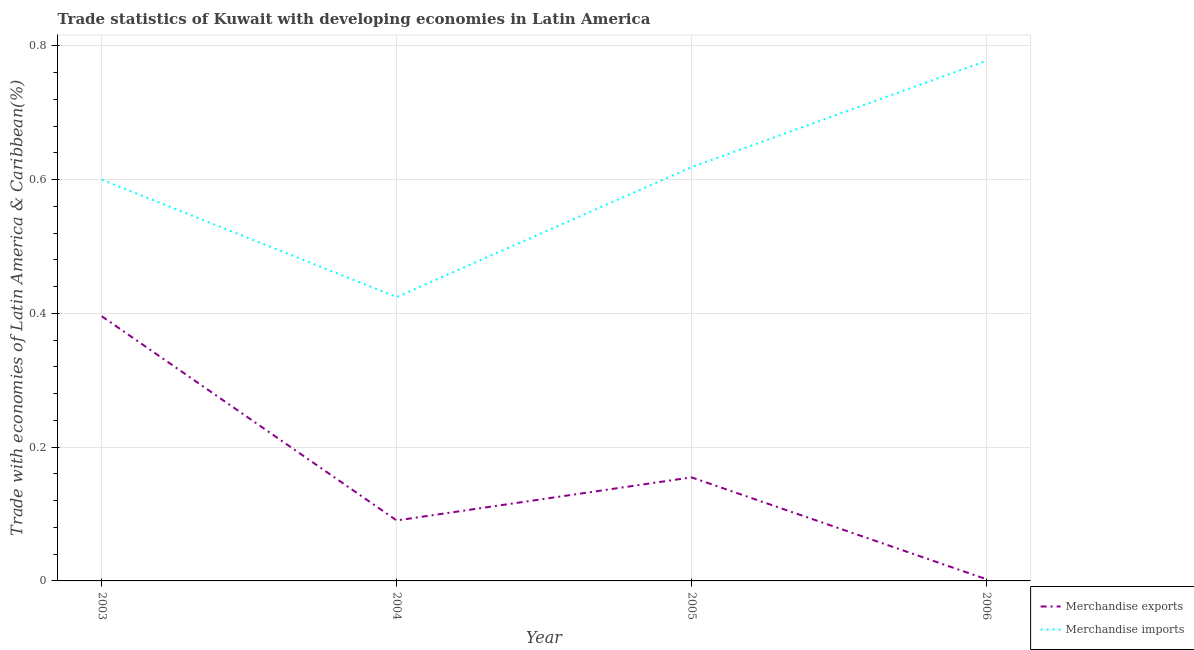How many different coloured lines are there?
Make the answer very short. 2. Does the line corresponding to merchandise imports intersect with the line corresponding to merchandise exports?
Give a very brief answer. No. Is the number of lines equal to the number of legend labels?
Keep it short and to the point. Yes. What is the merchandise exports in 2003?
Your answer should be compact. 0.4. Across all years, what is the maximum merchandise exports?
Your response must be concise. 0.4. Across all years, what is the minimum merchandise imports?
Make the answer very short. 0.42. In which year was the merchandise imports maximum?
Provide a succinct answer. 2006. What is the total merchandise imports in the graph?
Make the answer very short. 2.42. What is the difference between the merchandise imports in 2005 and that in 2006?
Offer a very short reply. -0.16. What is the difference between the merchandise exports in 2003 and the merchandise imports in 2004?
Make the answer very short. -0.03. What is the average merchandise exports per year?
Your response must be concise. 0.16. In the year 2006, what is the difference between the merchandise imports and merchandise exports?
Make the answer very short. 0.78. In how many years, is the merchandise imports greater than 0.12 %?
Make the answer very short. 4. What is the ratio of the merchandise imports in 2004 to that in 2006?
Give a very brief answer. 0.55. Is the merchandise imports in 2005 less than that in 2006?
Ensure brevity in your answer.  Yes. Is the difference between the merchandise imports in 2003 and 2004 greater than the difference between the merchandise exports in 2003 and 2004?
Your answer should be very brief. No. What is the difference between the highest and the second highest merchandise exports?
Ensure brevity in your answer.  0.24. What is the difference between the highest and the lowest merchandise exports?
Give a very brief answer. 0.39. In how many years, is the merchandise imports greater than the average merchandise imports taken over all years?
Keep it short and to the point. 2. Does the merchandise exports monotonically increase over the years?
Give a very brief answer. No. Is the merchandise imports strictly greater than the merchandise exports over the years?
Give a very brief answer. Yes. Is the merchandise imports strictly less than the merchandise exports over the years?
Provide a succinct answer. No. How many years are there in the graph?
Your answer should be very brief. 4. Are the values on the major ticks of Y-axis written in scientific E-notation?
Keep it short and to the point. No. Does the graph contain any zero values?
Provide a short and direct response. No. Does the graph contain grids?
Provide a succinct answer. Yes. How many legend labels are there?
Give a very brief answer. 2. What is the title of the graph?
Provide a succinct answer. Trade statistics of Kuwait with developing economies in Latin America. What is the label or title of the Y-axis?
Offer a terse response. Trade with economies of Latin America & Caribbean(%). What is the Trade with economies of Latin America & Caribbean(%) of Merchandise exports in 2003?
Keep it short and to the point. 0.4. What is the Trade with economies of Latin America & Caribbean(%) of Merchandise imports in 2003?
Give a very brief answer. 0.6. What is the Trade with economies of Latin America & Caribbean(%) of Merchandise exports in 2004?
Your answer should be compact. 0.09. What is the Trade with economies of Latin America & Caribbean(%) of Merchandise imports in 2004?
Offer a terse response. 0.42. What is the Trade with economies of Latin America & Caribbean(%) of Merchandise exports in 2005?
Your response must be concise. 0.15. What is the Trade with economies of Latin America & Caribbean(%) of Merchandise imports in 2005?
Offer a very short reply. 0.62. What is the Trade with economies of Latin America & Caribbean(%) of Merchandise exports in 2006?
Your answer should be compact. 0. What is the Trade with economies of Latin America & Caribbean(%) of Merchandise imports in 2006?
Offer a terse response. 0.78. Across all years, what is the maximum Trade with economies of Latin America & Caribbean(%) in Merchandise exports?
Your answer should be compact. 0.4. Across all years, what is the maximum Trade with economies of Latin America & Caribbean(%) in Merchandise imports?
Offer a terse response. 0.78. Across all years, what is the minimum Trade with economies of Latin America & Caribbean(%) of Merchandise exports?
Offer a very short reply. 0. Across all years, what is the minimum Trade with economies of Latin America & Caribbean(%) of Merchandise imports?
Your answer should be very brief. 0.42. What is the total Trade with economies of Latin America & Caribbean(%) of Merchandise exports in the graph?
Offer a very short reply. 0.64. What is the total Trade with economies of Latin America & Caribbean(%) of Merchandise imports in the graph?
Keep it short and to the point. 2.42. What is the difference between the Trade with economies of Latin America & Caribbean(%) in Merchandise exports in 2003 and that in 2004?
Provide a succinct answer. 0.31. What is the difference between the Trade with economies of Latin America & Caribbean(%) in Merchandise imports in 2003 and that in 2004?
Provide a short and direct response. 0.18. What is the difference between the Trade with economies of Latin America & Caribbean(%) in Merchandise exports in 2003 and that in 2005?
Make the answer very short. 0.24. What is the difference between the Trade with economies of Latin America & Caribbean(%) in Merchandise imports in 2003 and that in 2005?
Offer a terse response. -0.02. What is the difference between the Trade with economies of Latin America & Caribbean(%) of Merchandise exports in 2003 and that in 2006?
Provide a short and direct response. 0.39. What is the difference between the Trade with economies of Latin America & Caribbean(%) of Merchandise imports in 2003 and that in 2006?
Your answer should be very brief. -0.18. What is the difference between the Trade with economies of Latin America & Caribbean(%) in Merchandise exports in 2004 and that in 2005?
Provide a short and direct response. -0.06. What is the difference between the Trade with economies of Latin America & Caribbean(%) of Merchandise imports in 2004 and that in 2005?
Your answer should be very brief. -0.19. What is the difference between the Trade with economies of Latin America & Caribbean(%) of Merchandise exports in 2004 and that in 2006?
Provide a short and direct response. 0.09. What is the difference between the Trade with economies of Latin America & Caribbean(%) in Merchandise imports in 2004 and that in 2006?
Give a very brief answer. -0.35. What is the difference between the Trade with economies of Latin America & Caribbean(%) in Merchandise exports in 2005 and that in 2006?
Keep it short and to the point. 0.15. What is the difference between the Trade with economies of Latin America & Caribbean(%) of Merchandise imports in 2005 and that in 2006?
Ensure brevity in your answer.  -0.16. What is the difference between the Trade with economies of Latin America & Caribbean(%) in Merchandise exports in 2003 and the Trade with economies of Latin America & Caribbean(%) in Merchandise imports in 2004?
Provide a short and direct response. -0.03. What is the difference between the Trade with economies of Latin America & Caribbean(%) in Merchandise exports in 2003 and the Trade with economies of Latin America & Caribbean(%) in Merchandise imports in 2005?
Give a very brief answer. -0.22. What is the difference between the Trade with economies of Latin America & Caribbean(%) of Merchandise exports in 2003 and the Trade with economies of Latin America & Caribbean(%) of Merchandise imports in 2006?
Your answer should be compact. -0.38. What is the difference between the Trade with economies of Latin America & Caribbean(%) of Merchandise exports in 2004 and the Trade with economies of Latin America & Caribbean(%) of Merchandise imports in 2005?
Keep it short and to the point. -0.53. What is the difference between the Trade with economies of Latin America & Caribbean(%) of Merchandise exports in 2004 and the Trade with economies of Latin America & Caribbean(%) of Merchandise imports in 2006?
Provide a succinct answer. -0.69. What is the difference between the Trade with economies of Latin America & Caribbean(%) in Merchandise exports in 2005 and the Trade with economies of Latin America & Caribbean(%) in Merchandise imports in 2006?
Offer a very short reply. -0.62. What is the average Trade with economies of Latin America & Caribbean(%) in Merchandise exports per year?
Provide a succinct answer. 0.16. What is the average Trade with economies of Latin America & Caribbean(%) in Merchandise imports per year?
Keep it short and to the point. 0.61. In the year 2003, what is the difference between the Trade with economies of Latin America & Caribbean(%) in Merchandise exports and Trade with economies of Latin America & Caribbean(%) in Merchandise imports?
Make the answer very short. -0.2. In the year 2004, what is the difference between the Trade with economies of Latin America & Caribbean(%) in Merchandise exports and Trade with economies of Latin America & Caribbean(%) in Merchandise imports?
Your answer should be compact. -0.33. In the year 2005, what is the difference between the Trade with economies of Latin America & Caribbean(%) in Merchandise exports and Trade with economies of Latin America & Caribbean(%) in Merchandise imports?
Provide a short and direct response. -0.46. In the year 2006, what is the difference between the Trade with economies of Latin America & Caribbean(%) in Merchandise exports and Trade with economies of Latin America & Caribbean(%) in Merchandise imports?
Your response must be concise. -0.78. What is the ratio of the Trade with economies of Latin America & Caribbean(%) in Merchandise exports in 2003 to that in 2004?
Provide a succinct answer. 4.38. What is the ratio of the Trade with economies of Latin America & Caribbean(%) of Merchandise imports in 2003 to that in 2004?
Make the answer very short. 1.41. What is the ratio of the Trade with economies of Latin America & Caribbean(%) in Merchandise exports in 2003 to that in 2005?
Your response must be concise. 2.56. What is the ratio of the Trade with economies of Latin America & Caribbean(%) of Merchandise imports in 2003 to that in 2005?
Keep it short and to the point. 0.97. What is the ratio of the Trade with economies of Latin America & Caribbean(%) in Merchandise exports in 2003 to that in 2006?
Keep it short and to the point. 153.11. What is the ratio of the Trade with economies of Latin America & Caribbean(%) of Merchandise imports in 2003 to that in 2006?
Ensure brevity in your answer.  0.77. What is the ratio of the Trade with economies of Latin America & Caribbean(%) of Merchandise exports in 2004 to that in 2005?
Your answer should be compact. 0.58. What is the ratio of the Trade with economies of Latin America & Caribbean(%) of Merchandise imports in 2004 to that in 2005?
Provide a short and direct response. 0.69. What is the ratio of the Trade with economies of Latin America & Caribbean(%) of Merchandise exports in 2004 to that in 2006?
Provide a succinct answer. 34.98. What is the ratio of the Trade with economies of Latin America & Caribbean(%) of Merchandise imports in 2004 to that in 2006?
Provide a succinct answer. 0.55. What is the ratio of the Trade with economies of Latin America & Caribbean(%) in Merchandise exports in 2005 to that in 2006?
Offer a very short reply. 59.91. What is the ratio of the Trade with economies of Latin America & Caribbean(%) in Merchandise imports in 2005 to that in 2006?
Ensure brevity in your answer.  0.8. What is the difference between the highest and the second highest Trade with economies of Latin America & Caribbean(%) in Merchandise exports?
Keep it short and to the point. 0.24. What is the difference between the highest and the second highest Trade with economies of Latin America & Caribbean(%) in Merchandise imports?
Provide a succinct answer. 0.16. What is the difference between the highest and the lowest Trade with economies of Latin America & Caribbean(%) of Merchandise exports?
Your answer should be compact. 0.39. What is the difference between the highest and the lowest Trade with economies of Latin America & Caribbean(%) in Merchandise imports?
Keep it short and to the point. 0.35. 